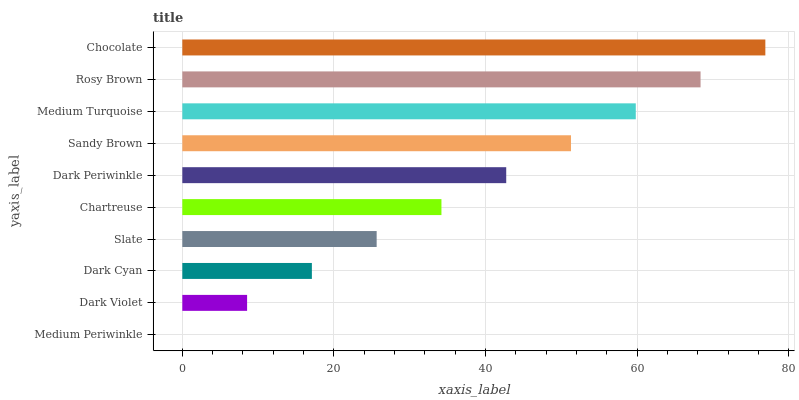Is Medium Periwinkle the minimum?
Answer yes or no. Yes. Is Chocolate the maximum?
Answer yes or no. Yes. Is Dark Violet the minimum?
Answer yes or no. No. Is Dark Violet the maximum?
Answer yes or no. No. Is Dark Violet greater than Medium Periwinkle?
Answer yes or no. Yes. Is Medium Periwinkle less than Dark Violet?
Answer yes or no. Yes. Is Medium Periwinkle greater than Dark Violet?
Answer yes or no. No. Is Dark Violet less than Medium Periwinkle?
Answer yes or no. No. Is Dark Periwinkle the high median?
Answer yes or no. Yes. Is Chartreuse the low median?
Answer yes or no. Yes. Is Medium Turquoise the high median?
Answer yes or no. No. Is Dark Cyan the low median?
Answer yes or no. No. 